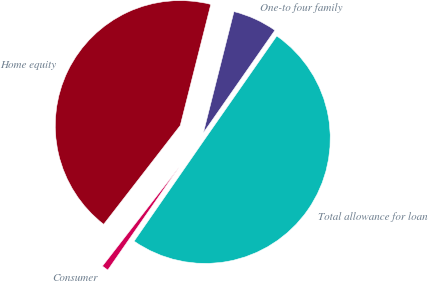<chart> <loc_0><loc_0><loc_500><loc_500><pie_chart><fcel>One-to four family<fcel>Home equity<fcel>Consumer<fcel>Total allowance for loan<nl><fcel>5.76%<fcel>43.44%<fcel>0.85%<fcel>49.95%<nl></chart> 